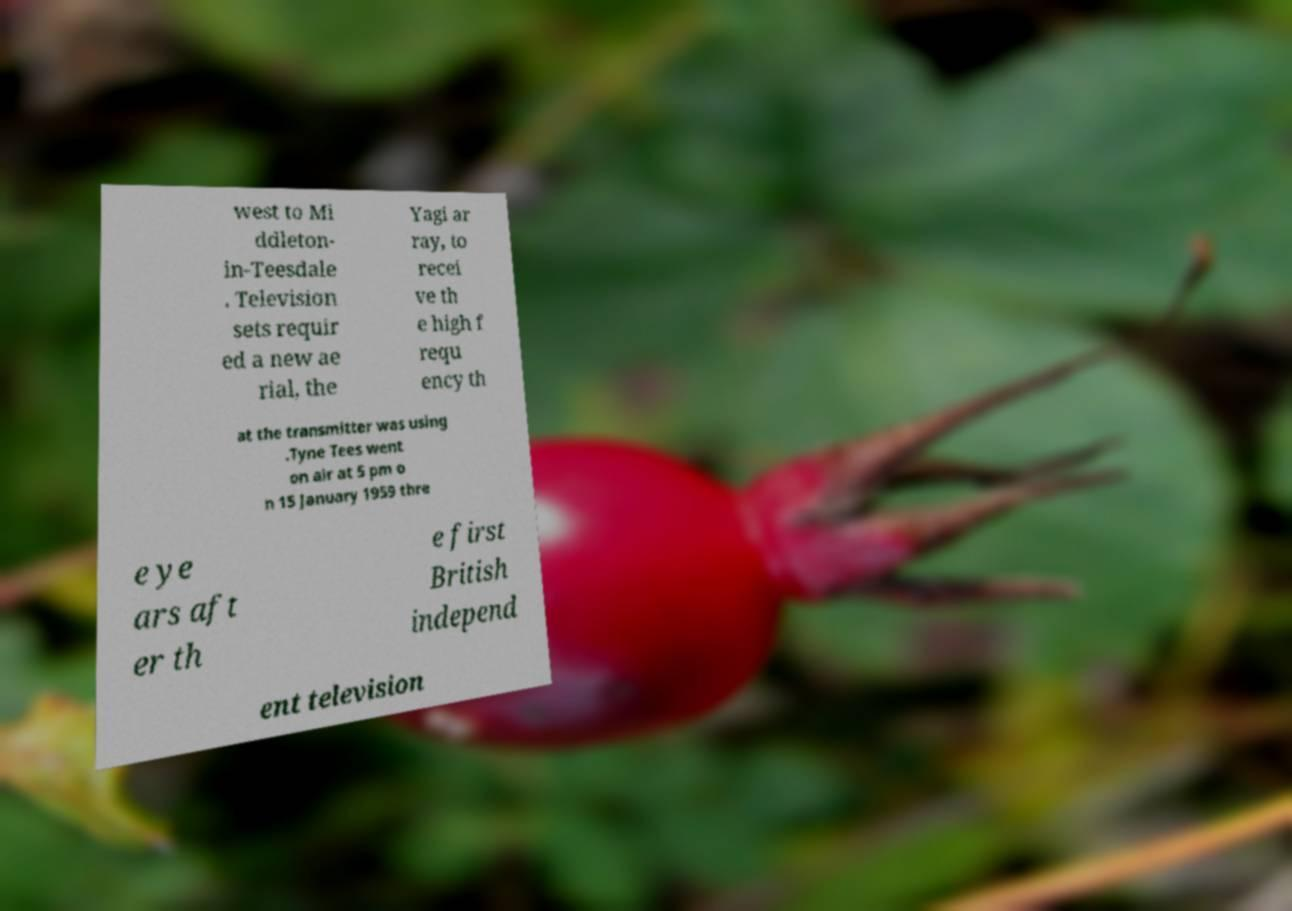Please identify and transcribe the text found in this image. west to Mi ddleton- in-Teesdale . Television sets requir ed a new ae rial, the Yagi ar ray, to recei ve th e high f requ ency th at the transmitter was using .Tyne Tees went on air at 5 pm o n 15 January 1959 thre e ye ars aft er th e first British independ ent television 